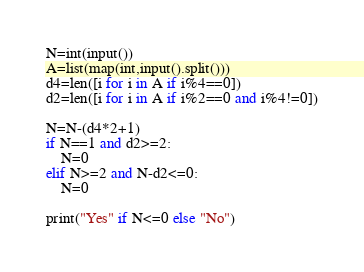<code> <loc_0><loc_0><loc_500><loc_500><_Python_>N=int(input())
A=list(map(int,input().split()))
d4=len([i for i in A if i%4==0])
d2=len([i for i in A if i%2==0 and i%4!=0])

N=N-(d4*2+1)
if N==1 and d2>=2:
    N=0
elif N>=2 and N-d2<=0:
    N=0

print("Yes" if N<=0 else "No")
</code> 